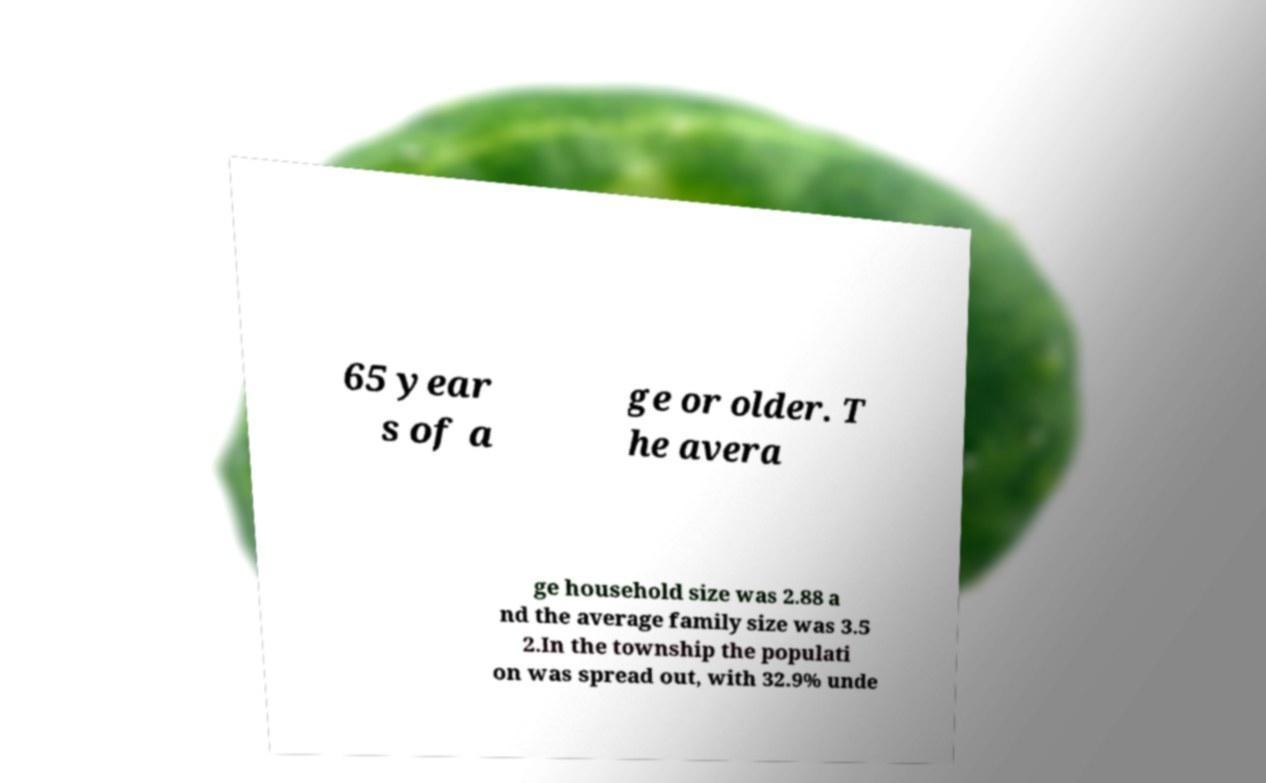Can you accurately transcribe the text from the provided image for me? 65 year s of a ge or older. T he avera ge household size was 2.88 a nd the average family size was 3.5 2.In the township the populati on was spread out, with 32.9% unde 